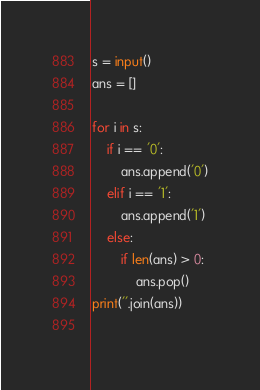Convert code to text. <code><loc_0><loc_0><loc_500><loc_500><_Python_>s = input()
ans = []

for i in s:
    if i == '0':
        ans.append('0')
    elif i == '1':
        ans.append('1')
    else:
        if len(ans) > 0:
            ans.pop()
print(''.join(ans))
        
</code> 